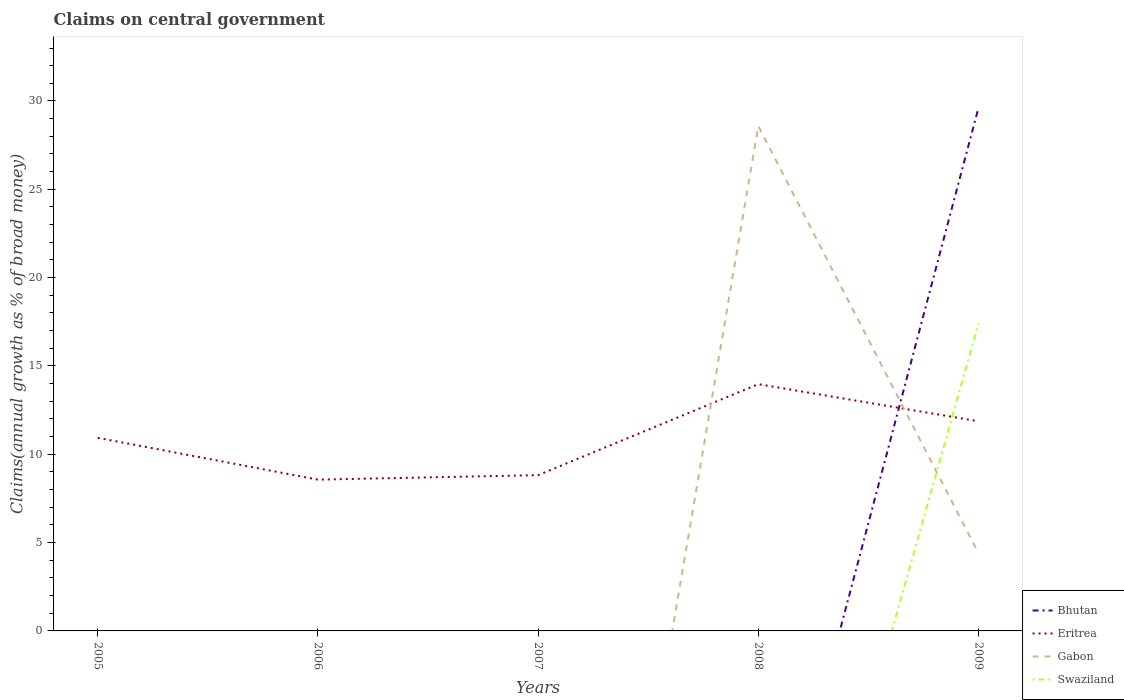How many different coloured lines are there?
Provide a short and direct response. 4. Across all years, what is the maximum percentage of broad money claimed on centeral government in Eritrea?
Provide a succinct answer. 8.56. What is the total percentage of broad money claimed on centeral government in Eritrea in the graph?
Provide a short and direct response. -5.41. What is the difference between the highest and the second highest percentage of broad money claimed on centeral government in Swaziland?
Give a very brief answer. 17.4. What is the difference between the highest and the lowest percentage of broad money claimed on centeral government in Gabon?
Your answer should be compact. 1. Is the percentage of broad money claimed on centeral government in Swaziland strictly greater than the percentage of broad money claimed on centeral government in Eritrea over the years?
Offer a very short reply. No. What is the difference between two consecutive major ticks on the Y-axis?
Offer a terse response. 5. Are the values on the major ticks of Y-axis written in scientific E-notation?
Make the answer very short. No. What is the title of the graph?
Your response must be concise. Claims on central government. Does "Montenegro" appear as one of the legend labels in the graph?
Provide a succinct answer. No. What is the label or title of the X-axis?
Your response must be concise. Years. What is the label or title of the Y-axis?
Your answer should be very brief. Claims(annual growth as % of broad money). What is the Claims(annual growth as % of broad money) in Bhutan in 2005?
Keep it short and to the point. 0. What is the Claims(annual growth as % of broad money) in Eritrea in 2005?
Provide a short and direct response. 10.93. What is the Claims(annual growth as % of broad money) of Swaziland in 2005?
Keep it short and to the point. 0. What is the Claims(annual growth as % of broad money) of Eritrea in 2006?
Ensure brevity in your answer.  8.56. What is the Claims(annual growth as % of broad money) in Eritrea in 2007?
Ensure brevity in your answer.  8.82. What is the Claims(annual growth as % of broad money) of Gabon in 2007?
Give a very brief answer. 0. What is the Claims(annual growth as % of broad money) of Bhutan in 2008?
Ensure brevity in your answer.  0. What is the Claims(annual growth as % of broad money) of Eritrea in 2008?
Ensure brevity in your answer.  13.97. What is the Claims(annual growth as % of broad money) of Gabon in 2008?
Your response must be concise. 28.58. What is the Claims(annual growth as % of broad money) in Bhutan in 2009?
Your answer should be compact. 29.62. What is the Claims(annual growth as % of broad money) in Eritrea in 2009?
Make the answer very short. 11.87. What is the Claims(annual growth as % of broad money) of Gabon in 2009?
Offer a terse response. 4.4. What is the Claims(annual growth as % of broad money) of Swaziland in 2009?
Ensure brevity in your answer.  17.4. Across all years, what is the maximum Claims(annual growth as % of broad money) of Bhutan?
Your answer should be compact. 29.62. Across all years, what is the maximum Claims(annual growth as % of broad money) of Eritrea?
Offer a terse response. 13.97. Across all years, what is the maximum Claims(annual growth as % of broad money) in Gabon?
Keep it short and to the point. 28.58. Across all years, what is the maximum Claims(annual growth as % of broad money) in Swaziland?
Your answer should be compact. 17.4. Across all years, what is the minimum Claims(annual growth as % of broad money) of Bhutan?
Ensure brevity in your answer.  0. Across all years, what is the minimum Claims(annual growth as % of broad money) of Eritrea?
Offer a terse response. 8.56. What is the total Claims(annual growth as % of broad money) of Bhutan in the graph?
Keep it short and to the point. 29.62. What is the total Claims(annual growth as % of broad money) of Eritrea in the graph?
Ensure brevity in your answer.  54.16. What is the total Claims(annual growth as % of broad money) in Gabon in the graph?
Your response must be concise. 32.98. What is the total Claims(annual growth as % of broad money) of Swaziland in the graph?
Make the answer very short. 17.4. What is the difference between the Claims(annual growth as % of broad money) in Eritrea in 2005 and that in 2006?
Ensure brevity in your answer.  2.37. What is the difference between the Claims(annual growth as % of broad money) in Eritrea in 2005 and that in 2007?
Your answer should be very brief. 2.11. What is the difference between the Claims(annual growth as % of broad money) of Eritrea in 2005 and that in 2008?
Provide a short and direct response. -3.04. What is the difference between the Claims(annual growth as % of broad money) of Eritrea in 2005 and that in 2009?
Your response must be concise. -0.94. What is the difference between the Claims(annual growth as % of broad money) in Eritrea in 2006 and that in 2007?
Your answer should be very brief. -0.25. What is the difference between the Claims(annual growth as % of broad money) in Eritrea in 2006 and that in 2008?
Your answer should be very brief. -5.41. What is the difference between the Claims(annual growth as % of broad money) in Eritrea in 2006 and that in 2009?
Make the answer very short. -3.3. What is the difference between the Claims(annual growth as % of broad money) in Eritrea in 2007 and that in 2008?
Make the answer very short. -5.15. What is the difference between the Claims(annual growth as % of broad money) in Eritrea in 2007 and that in 2009?
Keep it short and to the point. -3.05. What is the difference between the Claims(annual growth as % of broad money) in Eritrea in 2008 and that in 2009?
Your response must be concise. 2.1. What is the difference between the Claims(annual growth as % of broad money) in Gabon in 2008 and that in 2009?
Your answer should be compact. 24.18. What is the difference between the Claims(annual growth as % of broad money) of Eritrea in 2005 and the Claims(annual growth as % of broad money) of Gabon in 2008?
Your answer should be very brief. -17.65. What is the difference between the Claims(annual growth as % of broad money) in Eritrea in 2005 and the Claims(annual growth as % of broad money) in Gabon in 2009?
Your answer should be very brief. 6.54. What is the difference between the Claims(annual growth as % of broad money) of Eritrea in 2005 and the Claims(annual growth as % of broad money) of Swaziland in 2009?
Provide a short and direct response. -6.47. What is the difference between the Claims(annual growth as % of broad money) of Eritrea in 2006 and the Claims(annual growth as % of broad money) of Gabon in 2008?
Give a very brief answer. -20.02. What is the difference between the Claims(annual growth as % of broad money) of Eritrea in 2006 and the Claims(annual growth as % of broad money) of Gabon in 2009?
Keep it short and to the point. 4.17. What is the difference between the Claims(annual growth as % of broad money) of Eritrea in 2006 and the Claims(annual growth as % of broad money) of Swaziland in 2009?
Ensure brevity in your answer.  -8.83. What is the difference between the Claims(annual growth as % of broad money) in Eritrea in 2007 and the Claims(annual growth as % of broad money) in Gabon in 2008?
Offer a very short reply. -19.76. What is the difference between the Claims(annual growth as % of broad money) of Eritrea in 2007 and the Claims(annual growth as % of broad money) of Gabon in 2009?
Your response must be concise. 4.42. What is the difference between the Claims(annual growth as % of broad money) of Eritrea in 2007 and the Claims(annual growth as % of broad money) of Swaziland in 2009?
Offer a terse response. -8.58. What is the difference between the Claims(annual growth as % of broad money) of Eritrea in 2008 and the Claims(annual growth as % of broad money) of Gabon in 2009?
Your answer should be compact. 9.57. What is the difference between the Claims(annual growth as % of broad money) in Eritrea in 2008 and the Claims(annual growth as % of broad money) in Swaziland in 2009?
Your answer should be compact. -3.43. What is the difference between the Claims(annual growth as % of broad money) of Gabon in 2008 and the Claims(annual growth as % of broad money) of Swaziland in 2009?
Offer a very short reply. 11.18. What is the average Claims(annual growth as % of broad money) of Bhutan per year?
Provide a short and direct response. 5.92. What is the average Claims(annual growth as % of broad money) of Eritrea per year?
Your answer should be very brief. 10.83. What is the average Claims(annual growth as % of broad money) of Gabon per year?
Your answer should be very brief. 6.6. What is the average Claims(annual growth as % of broad money) of Swaziland per year?
Provide a short and direct response. 3.48. In the year 2008, what is the difference between the Claims(annual growth as % of broad money) of Eritrea and Claims(annual growth as % of broad money) of Gabon?
Provide a short and direct response. -14.61. In the year 2009, what is the difference between the Claims(annual growth as % of broad money) of Bhutan and Claims(annual growth as % of broad money) of Eritrea?
Your response must be concise. 17.75. In the year 2009, what is the difference between the Claims(annual growth as % of broad money) of Bhutan and Claims(annual growth as % of broad money) of Gabon?
Your answer should be very brief. 25.23. In the year 2009, what is the difference between the Claims(annual growth as % of broad money) in Bhutan and Claims(annual growth as % of broad money) in Swaziland?
Provide a succinct answer. 12.22. In the year 2009, what is the difference between the Claims(annual growth as % of broad money) in Eritrea and Claims(annual growth as % of broad money) in Gabon?
Offer a very short reply. 7.47. In the year 2009, what is the difference between the Claims(annual growth as % of broad money) of Eritrea and Claims(annual growth as % of broad money) of Swaziland?
Provide a short and direct response. -5.53. In the year 2009, what is the difference between the Claims(annual growth as % of broad money) of Gabon and Claims(annual growth as % of broad money) of Swaziland?
Provide a succinct answer. -13. What is the ratio of the Claims(annual growth as % of broad money) of Eritrea in 2005 to that in 2006?
Make the answer very short. 1.28. What is the ratio of the Claims(annual growth as % of broad money) of Eritrea in 2005 to that in 2007?
Keep it short and to the point. 1.24. What is the ratio of the Claims(annual growth as % of broad money) in Eritrea in 2005 to that in 2008?
Offer a very short reply. 0.78. What is the ratio of the Claims(annual growth as % of broad money) in Eritrea in 2005 to that in 2009?
Your answer should be compact. 0.92. What is the ratio of the Claims(annual growth as % of broad money) of Eritrea in 2006 to that in 2007?
Provide a short and direct response. 0.97. What is the ratio of the Claims(annual growth as % of broad money) of Eritrea in 2006 to that in 2008?
Give a very brief answer. 0.61. What is the ratio of the Claims(annual growth as % of broad money) in Eritrea in 2006 to that in 2009?
Your response must be concise. 0.72. What is the ratio of the Claims(annual growth as % of broad money) of Eritrea in 2007 to that in 2008?
Your answer should be compact. 0.63. What is the ratio of the Claims(annual growth as % of broad money) in Eritrea in 2007 to that in 2009?
Give a very brief answer. 0.74. What is the ratio of the Claims(annual growth as % of broad money) of Eritrea in 2008 to that in 2009?
Give a very brief answer. 1.18. What is the ratio of the Claims(annual growth as % of broad money) in Gabon in 2008 to that in 2009?
Provide a short and direct response. 6.5. What is the difference between the highest and the second highest Claims(annual growth as % of broad money) in Eritrea?
Give a very brief answer. 2.1. What is the difference between the highest and the lowest Claims(annual growth as % of broad money) in Bhutan?
Provide a short and direct response. 29.62. What is the difference between the highest and the lowest Claims(annual growth as % of broad money) of Eritrea?
Provide a succinct answer. 5.41. What is the difference between the highest and the lowest Claims(annual growth as % of broad money) of Gabon?
Offer a very short reply. 28.58. What is the difference between the highest and the lowest Claims(annual growth as % of broad money) in Swaziland?
Offer a very short reply. 17.4. 